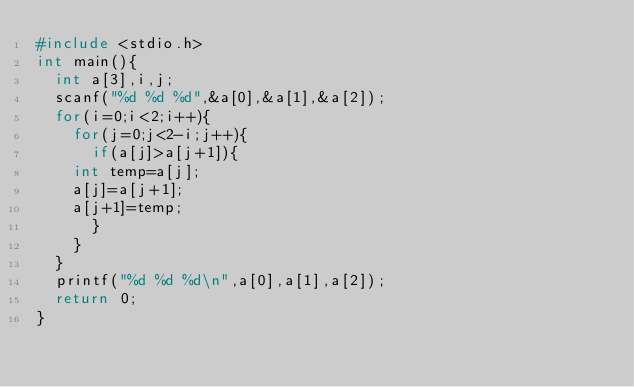Convert code to text. <code><loc_0><loc_0><loc_500><loc_500><_C_>#include <stdio.h>
int main(){
  int a[3],i,j;
  scanf("%d %d %d",&a[0],&a[1],&a[2]);
  for(i=0;i<2;i++){
    for(j=0;j<2-i;j++){
      if(a[j]>a[j+1]){
	int temp=a[j];
	a[j]=a[j+1];
	a[j+1]=temp;
      }
    }
  }
  printf("%d %d %d\n",a[0],a[1],a[2]);
  return 0;
}</code> 